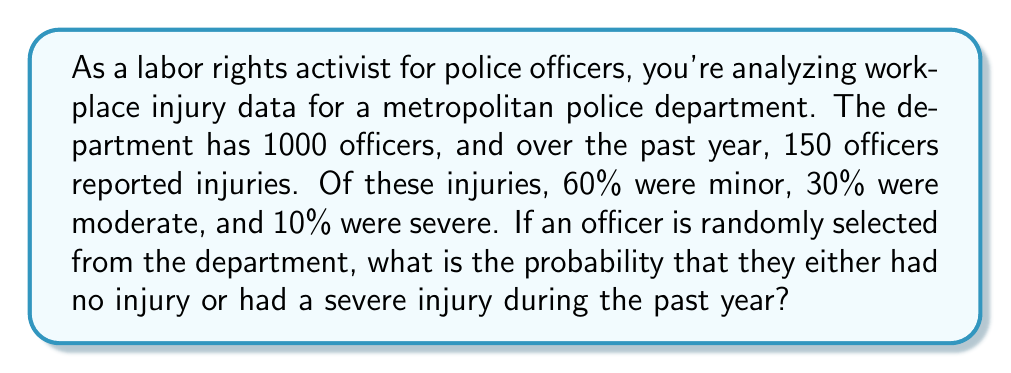Teach me how to tackle this problem. Let's approach this step-by-step:

1) First, let's identify the probabilities we need:
   - Probability of no injury
   - Probability of severe injury

2) Calculate the probability of any injury:
   $P(\text{injury}) = \frac{150}{1000} = 0.15$

3) Calculate the probability of no injury:
   $P(\text{no injury}) = 1 - P(\text{injury}) = 1 - 0.15 = 0.85$

4) Calculate the probability of severe injury:
   $P(\text{severe injury}) = P(\text{injury}) \times P(\text{severe | injury})$
   $= 0.15 \times 0.10 = 0.015$

5) The question asks for the probability of either no injury or severe injury. These are mutually exclusive events, so we can add their probabilities:

   $P(\text{no injury or severe injury}) = P(\text{no injury}) + P(\text{severe injury})$
   $= 0.85 + 0.015 = 0.865$

Therefore, the probability that a randomly selected officer either had no injury or had a severe injury is 0.865 or 86.5%.
Answer: 0.865 or 86.5% 